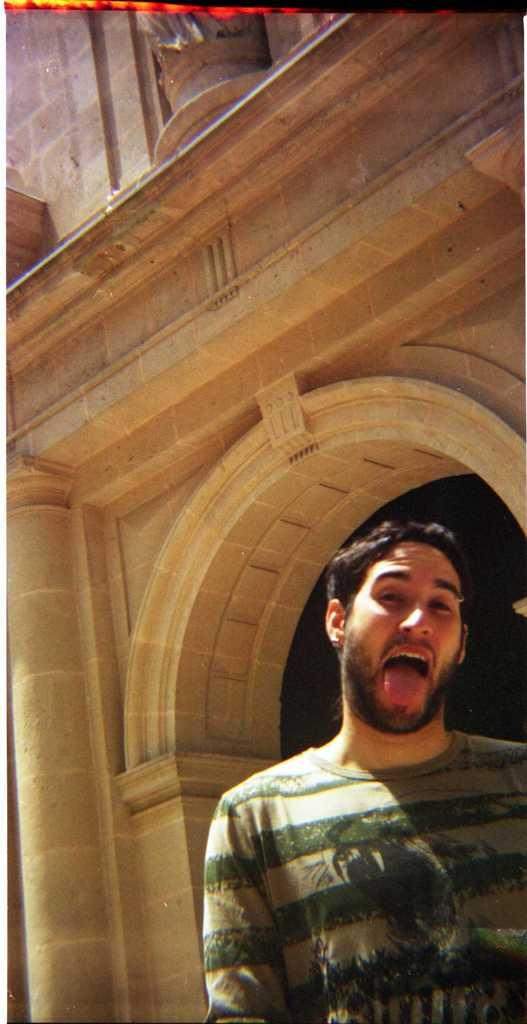Who is present in the image? There is a man in the image. What is the man doing with his tongue? The man has his tongue out in the image. What can be seen in the background of the image? There is a building in the background of the image. What type of meal is the man eating in the image? There is no meal present in the image; the man has his tongue out. What kind of van can be seen parked near the building in the image? There is no van present in the image; only the man and the building are visible. 